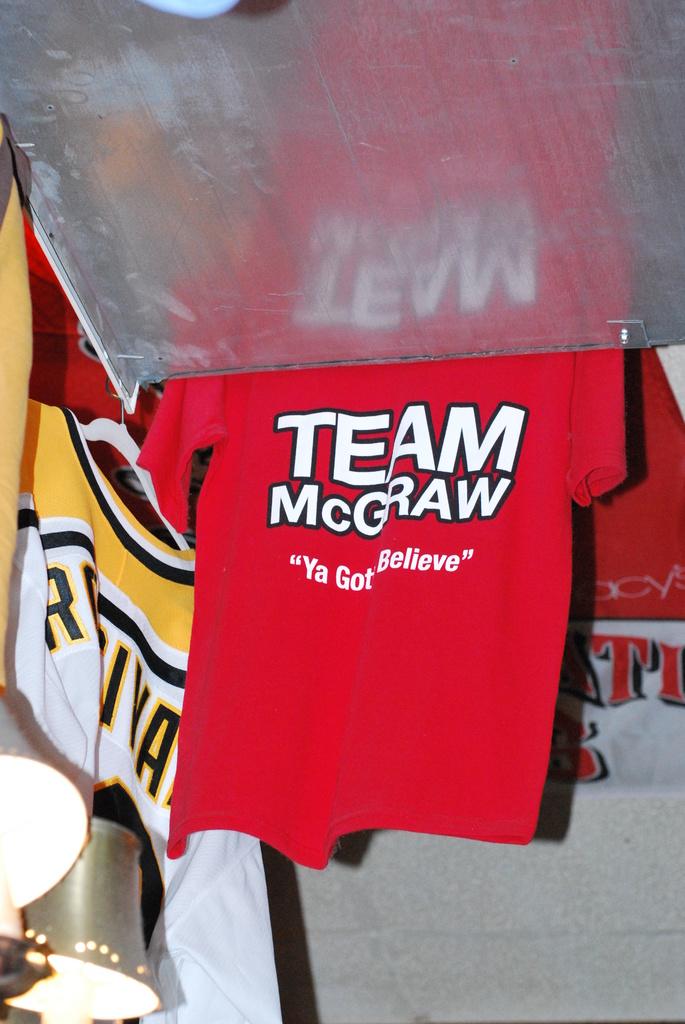What is this t-shirt advertising?
Offer a terse response. Team mcgraw. What's the tagline of the shirt?
Make the answer very short. Ya gotta believe. 